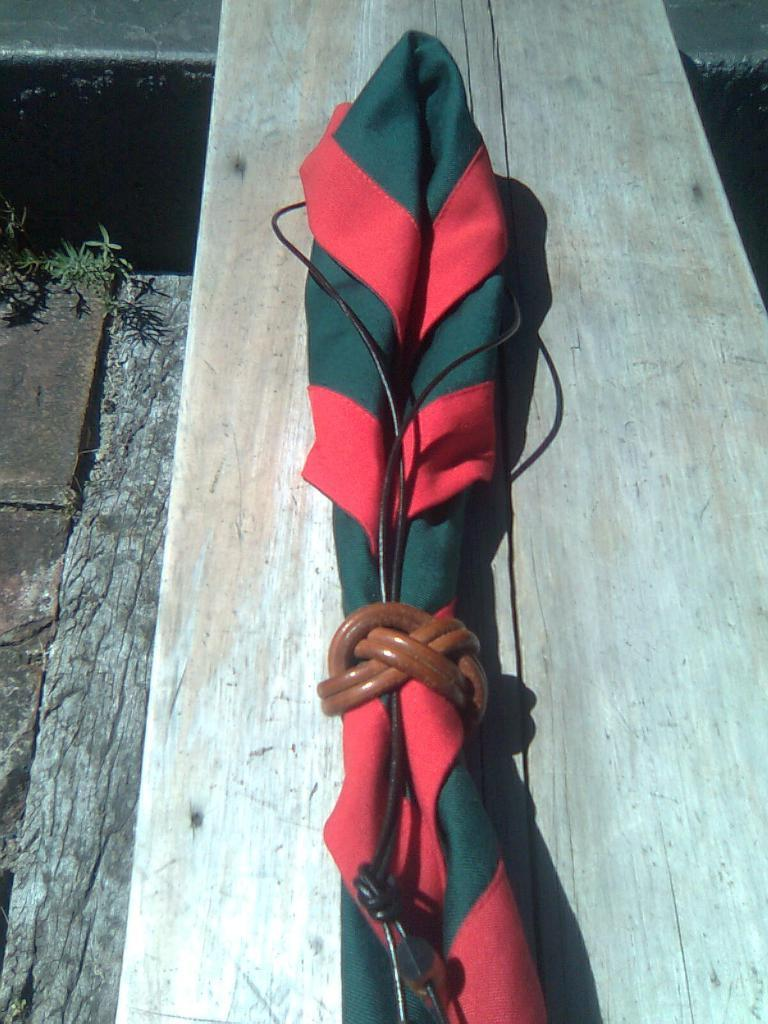What is placed on the wooden bench in the image? There is an object on a wooden bench in the image. What type of surface is below the wooden bench? There is a rock surface below the bench. How many fowls can be seen on the rock surface in the image? There are no fowls present on the rock surface in the image. What type of ring is visible on the object on the wooden bench? There is no ring visible on the object on the wooden bench in the image. 